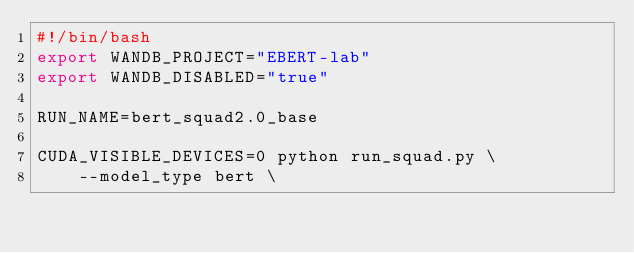Convert code to text. <code><loc_0><loc_0><loc_500><loc_500><_Bash_>#!/bin/bash
export WANDB_PROJECT="EBERT-lab"
export WANDB_DISABLED="true"

RUN_NAME=bert_squad2.0_base

CUDA_VISIBLE_DEVICES=0 python run_squad.py \
    --model_type bert \</code> 